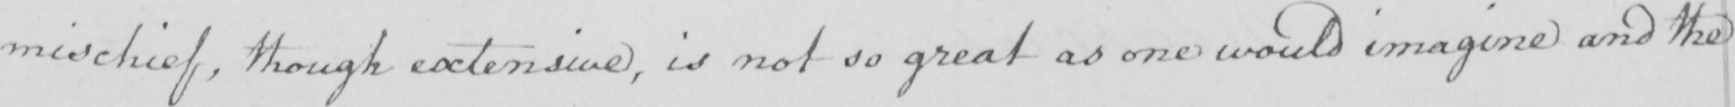Please transcribe the handwritten text in this image. mischief , though extensive , is not so great as one would imagine and the 